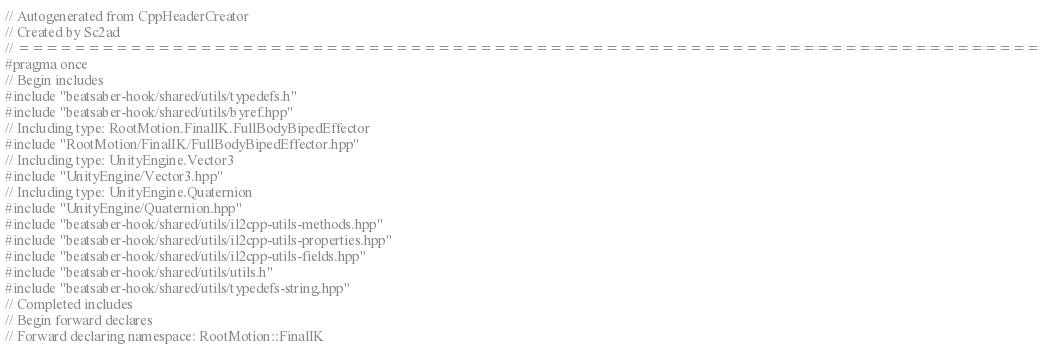<code> <loc_0><loc_0><loc_500><loc_500><_C++_>// Autogenerated from CppHeaderCreator
// Created by Sc2ad
// =========================================================================
#pragma once
// Begin includes
#include "beatsaber-hook/shared/utils/typedefs.h"
#include "beatsaber-hook/shared/utils/byref.hpp"
// Including type: RootMotion.FinalIK.FullBodyBipedEffector
#include "RootMotion/FinalIK/FullBodyBipedEffector.hpp"
// Including type: UnityEngine.Vector3
#include "UnityEngine/Vector3.hpp"
// Including type: UnityEngine.Quaternion
#include "UnityEngine/Quaternion.hpp"
#include "beatsaber-hook/shared/utils/il2cpp-utils-methods.hpp"
#include "beatsaber-hook/shared/utils/il2cpp-utils-properties.hpp"
#include "beatsaber-hook/shared/utils/il2cpp-utils-fields.hpp"
#include "beatsaber-hook/shared/utils/utils.h"
#include "beatsaber-hook/shared/utils/typedefs-string.hpp"
// Completed includes
// Begin forward declares
// Forward declaring namespace: RootMotion::FinalIK</code> 